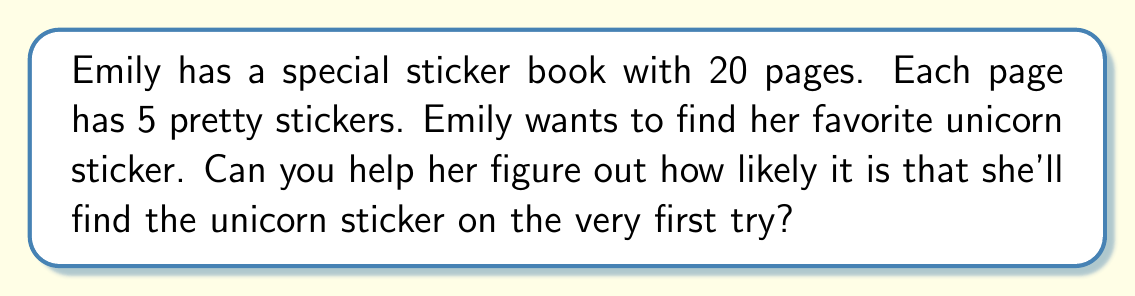Can you solve this math problem? Let's break this down into simple steps:

1. First, we need to find out how many stickers are in the whole book:
   * There are 20 pages
   * Each page has 5 stickers
   * Total number of stickers = $20 \times 5 = 100$ stickers

2. Now, we know there's only one unicorn sticker Emily wants to find.

3. To find the probability, we use this formula:
   $$ \text{Probability} = \frac{\text{Number of favorable outcomes}}{\text{Total number of possible outcomes}} $$

4. In this case:
   * Favorable outcome: 1 (the unicorn sticker)
   * Total possible outcomes: 100 (all the stickers in the book)

5. So, the probability is:
   $$ \text{Probability} = \frac{1}{100} = 0.01 $$

This means Emily has a 1 in 100 chance of finding her unicorn sticker on the first try.
Answer: The probability of Emily finding her unicorn sticker on the first try is $\frac{1}{100}$ or 0.01 or 1%. 